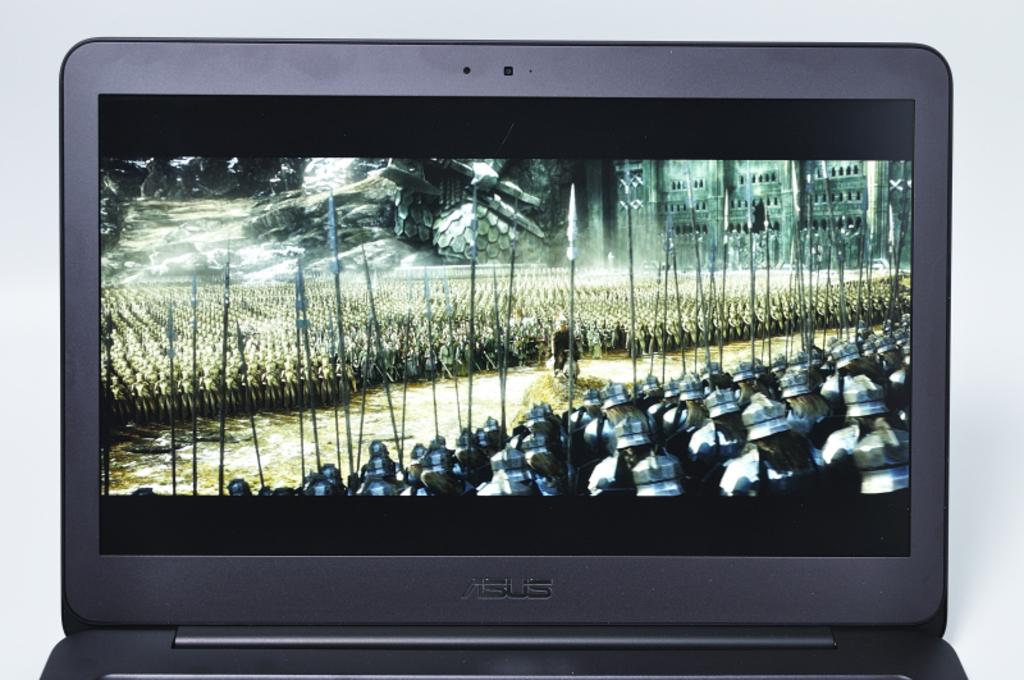<image>
Offer a succinct explanation of the picture presented. An Asus laptop is open with a movie on its screen. 